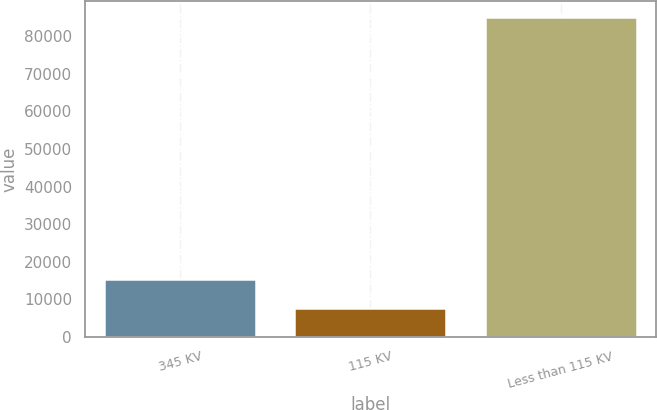Convert chart. <chart><loc_0><loc_0><loc_500><loc_500><bar_chart><fcel>345 KV<fcel>115 KV<fcel>Less than 115 KV<nl><fcel>15272.1<fcel>7517<fcel>85068<nl></chart> 